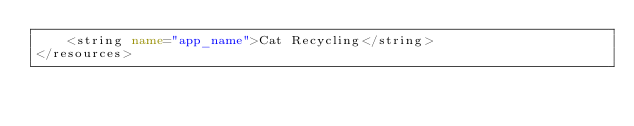<code> <loc_0><loc_0><loc_500><loc_500><_XML_>    <string name="app_name">Cat Recycling</string>
</resources></code> 